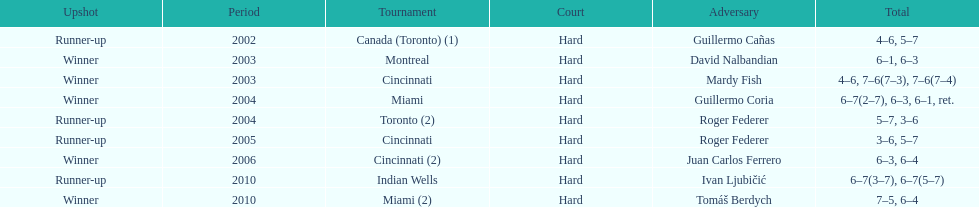How many times was roger federer a runner-up? 2. 